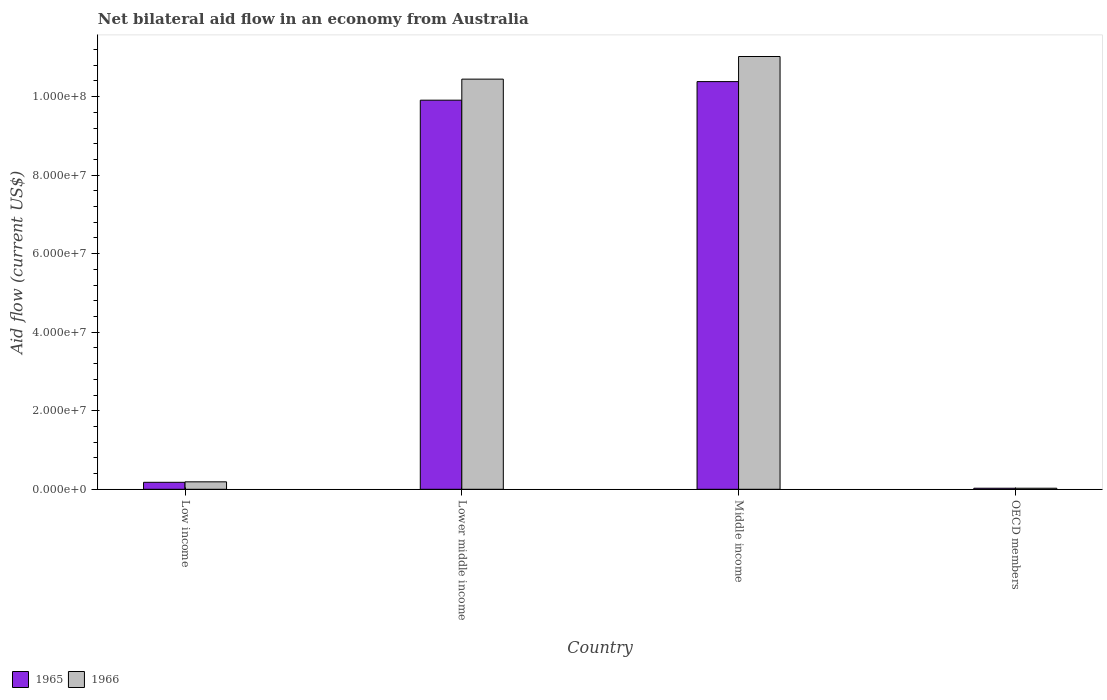Are the number of bars per tick equal to the number of legend labels?
Give a very brief answer. Yes. How many bars are there on the 3rd tick from the right?
Provide a succinct answer. 2. In how many cases, is the number of bars for a given country not equal to the number of legend labels?
Your response must be concise. 0. What is the net bilateral aid flow in 1965 in Lower middle income?
Your answer should be compact. 9.91e+07. Across all countries, what is the maximum net bilateral aid flow in 1965?
Keep it short and to the point. 1.04e+08. Across all countries, what is the minimum net bilateral aid flow in 1965?
Ensure brevity in your answer.  2.70e+05. What is the total net bilateral aid flow in 1965 in the graph?
Make the answer very short. 2.05e+08. What is the difference between the net bilateral aid flow in 1965 in Low income and that in OECD members?
Your response must be concise. 1.51e+06. What is the difference between the net bilateral aid flow in 1965 in Lower middle income and the net bilateral aid flow in 1966 in Low income?
Your answer should be compact. 9.72e+07. What is the average net bilateral aid flow in 1965 per country?
Provide a succinct answer. 5.12e+07. What is the ratio of the net bilateral aid flow in 1965 in Lower middle income to that in Middle income?
Provide a succinct answer. 0.95. What is the difference between the highest and the second highest net bilateral aid flow in 1966?
Your answer should be compact. 1.08e+08. What is the difference between the highest and the lowest net bilateral aid flow in 1965?
Offer a terse response. 1.04e+08. In how many countries, is the net bilateral aid flow in 1965 greater than the average net bilateral aid flow in 1965 taken over all countries?
Your answer should be very brief. 2. What does the 1st bar from the left in Middle income represents?
Offer a terse response. 1965. What does the 1st bar from the right in Middle income represents?
Your answer should be compact. 1966. How many countries are there in the graph?
Provide a succinct answer. 4. Are the values on the major ticks of Y-axis written in scientific E-notation?
Your answer should be compact. Yes. Where does the legend appear in the graph?
Your answer should be compact. Bottom left. How are the legend labels stacked?
Provide a succinct answer. Horizontal. What is the title of the graph?
Keep it short and to the point. Net bilateral aid flow in an economy from Australia. Does "1996" appear as one of the legend labels in the graph?
Provide a succinct answer. No. What is the label or title of the X-axis?
Provide a succinct answer. Country. What is the Aid flow (current US$) of 1965 in Low income?
Give a very brief answer. 1.78e+06. What is the Aid flow (current US$) in 1966 in Low income?
Ensure brevity in your answer.  1.90e+06. What is the Aid flow (current US$) of 1965 in Lower middle income?
Provide a succinct answer. 9.91e+07. What is the Aid flow (current US$) of 1966 in Lower middle income?
Offer a terse response. 1.04e+08. What is the Aid flow (current US$) of 1965 in Middle income?
Your answer should be very brief. 1.04e+08. What is the Aid flow (current US$) of 1966 in Middle income?
Offer a terse response. 1.10e+08. What is the Aid flow (current US$) of 1966 in OECD members?
Offer a very short reply. 2.70e+05. Across all countries, what is the maximum Aid flow (current US$) of 1965?
Provide a succinct answer. 1.04e+08. Across all countries, what is the maximum Aid flow (current US$) in 1966?
Make the answer very short. 1.10e+08. Across all countries, what is the minimum Aid flow (current US$) of 1966?
Provide a short and direct response. 2.70e+05. What is the total Aid flow (current US$) of 1965 in the graph?
Provide a short and direct response. 2.05e+08. What is the total Aid flow (current US$) of 1966 in the graph?
Give a very brief answer. 2.17e+08. What is the difference between the Aid flow (current US$) in 1965 in Low income and that in Lower middle income?
Keep it short and to the point. -9.73e+07. What is the difference between the Aid flow (current US$) in 1966 in Low income and that in Lower middle income?
Offer a very short reply. -1.03e+08. What is the difference between the Aid flow (current US$) of 1965 in Low income and that in Middle income?
Your response must be concise. -1.02e+08. What is the difference between the Aid flow (current US$) in 1966 in Low income and that in Middle income?
Ensure brevity in your answer.  -1.08e+08. What is the difference between the Aid flow (current US$) of 1965 in Low income and that in OECD members?
Your answer should be very brief. 1.51e+06. What is the difference between the Aid flow (current US$) of 1966 in Low income and that in OECD members?
Offer a terse response. 1.63e+06. What is the difference between the Aid flow (current US$) in 1965 in Lower middle income and that in Middle income?
Make the answer very short. -4.73e+06. What is the difference between the Aid flow (current US$) in 1966 in Lower middle income and that in Middle income?
Give a very brief answer. -5.76e+06. What is the difference between the Aid flow (current US$) in 1965 in Lower middle income and that in OECD members?
Keep it short and to the point. 9.88e+07. What is the difference between the Aid flow (current US$) in 1966 in Lower middle income and that in OECD members?
Your answer should be compact. 1.04e+08. What is the difference between the Aid flow (current US$) in 1965 in Middle income and that in OECD members?
Your answer should be compact. 1.04e+08. What is the difference between the Aid flow (current US$) in 1966 in Middle income and that in OECD members?
Keep it short and to the point. 1.10e+08. What is the difference between the Aid flow (current US$) of 1965 in Low income and the Aid flow (current US$) of 1966 in Lower middle income?
Your answer should be compact. -1.03e+08. What is the difference between the Aid flow (current US$) in 1965 in Low income and the Aid flow (current US$) in 1966 in Middle income?
Keep it short and to the point. -1.08e+08. What is the difference between the Aid flow (current US$) of 1965 in Low income and the Aid flow (current US$) of 1966 in OECD members?
Give a very brief answer. 1.51e+06. What is the difference between the Aid flow (current US$) in 1965 in Lower middle income and the Aid flow (current US$) in 1966 in Middle income?
Make the answer very short. -1.11e+07. What is the difference between the Aid flow (current US$) of 1965 in Lower middle income and the Aid flow (current US$) of 1966 in OECD members?
Your answer should be very brief. 9.88e+07. What is the difference between the Aid flow (current US$) in 1965 in Middle income and the Aid flow (current US$) in 1966 in OECD members?
Provide a short and direct response. 1.04e+08. What is the average Aid flow (current US$) of 1965 per country?
Keep it short and to the point. 5.12e+07. What is the average Aid flow (current US$) in 1966 per country?
Give a very brief answer. 5.42e+07. What is the difference between the Aid flow (current US$) of 1965 and Aid flow (current US$) of 1966 in Low income?
Give a very brief answer. -1.20e+05. What is the difference between the Aid flow (current US$) in 1965 and Aid flow (current US$) in 1966 in Lower middle income?
Your answer should be very brief. -5.36e+06. What is the difference between the Aid flow (current US$) in 1965 and Aid flow (current US$) in 1966 in Middle income?
Keep it short and to the point. -6.39e+06. What is the ratio of the Aid flow (current US$) in 1965 in Low income to that in Lower middle income?
Your answer should be compact. 0.02. What is the ratio of the Aid flow (current US$) in 1966 in Low income to that in Lower middle income?
Offer a very short reply. 0.02. What is the ratio of the Aid flow (current US$) of 1965 in Low income to that in Middle income?
Ensure brevity in your answer.  0.02. What is the ratio of the Aid flow (current US$) of 1966 in Low income to that in Middle income?
Offer a terse response. 0.02. What is the ratio of the Aid flow (current US$) in 1965 in Low income to that in OECD members?
Ensure brevity in your answer.  6.59. What is the ratio of the Aid flow (current US$) in 1966 in Low income to that in OECD members?
Make the answer very short. 7.04. What is the ratio of the Aid flow (current US$) of 1965 in Lower middle income to that in Middle income?
Provide a short and direct response. 0.95. What is the ratio of the Aid flow (current US$) of 1966 in Lower middle income to that in Middle income?
Offer a terse response. 0.95. What is the ratio of the Aid flow (current US$) in 1965 in Lower middle income to that in OECD members?
Your response must be concise. 367. What is the ratio of the Aid flow (current US$) of 1966 in Lower middle income to that in OECD members?
Your answer should be compact. 386.85. What is the ratio of the Aid flow (current US$) in 1965 in Middle income to that in OECD members?
Offer a terse response. 384.52. What is the ratio of the Aid flow (current US$) in 1966 in Middle income to that in OECD members?
Your answer should be compact. 408.19. What is the difference between the highest and the second highest Aid flow (current US$) in 1965?
Your answer should be compact. 4.73e+06. What is the difference between the highest and the second highest Aid flow (current US$) of 1966?
Offer a terse response. 5.76e+06. What is the difference between the highest and the lowest Aid flow (current US$) in 1965?
Make the answer very short. 1.04e+08. What is the difference between the highest and the lowest Aid flow (current US$) of 1966?
Give a very brief answer. 1.10e+08. 